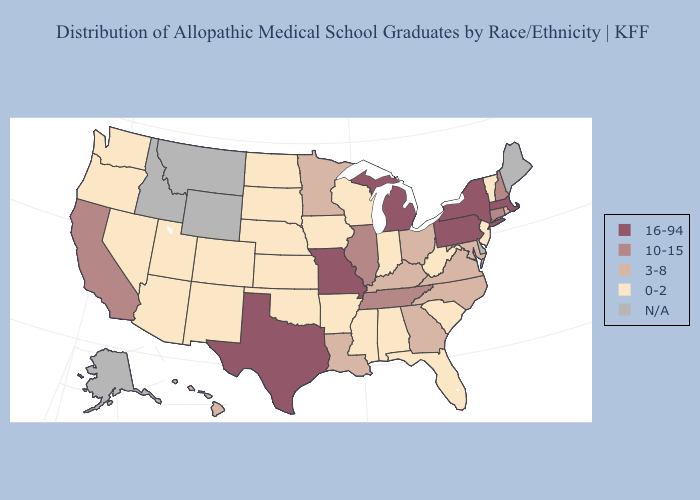Which states have the highest value in the USA?
Give a very brief answer. Massachusetts, Michigan, Missouri, New York, Pennsylvania, Texas. What is the highest value in the USA?
Short answer required. 16-94. What is the value of California?
Write a very short answer. 10-15. Does New Jersey have the highest value in the Northeast?
Short answer required. No. Does Minnesota have the lowest value in the USA?
Quick response, please. No. Name the states that have a value in the range N/A?
Give a very brief answer. Alaska, Delaware, Idaho, Maine, Montana, Wyoming. Among the states that border Wisconsin , which have the lowest value?
Short answer required. Iowa. Which states have the highest value in the USA?
Answer briefly. Massachusetts, Michigan, Missouri, New York, Pennsylvania, Texas. What is the value of Kansas?
Short answer required. 0-2. Does Rhode Island have the highest value in the Northeast?
Short answer required. No. Name the states that have a value in the range 3-8?
Quick response, please. Georgia, Hawaii, Kentucky, Louisiana, Maryland, Minnesota, North Carolina, Ohio, Rhode Island, Virginia. Name the states that have a value in the range 16-94?
Give a very brief answer. Massachusetts, Michigan, Missouri, New York, Pennsylvania, Texas. Name the states that have a value in the range 10-15?
Quick response, please. California, Connecticut, Illinois, New Hampshire, Tennessee. 